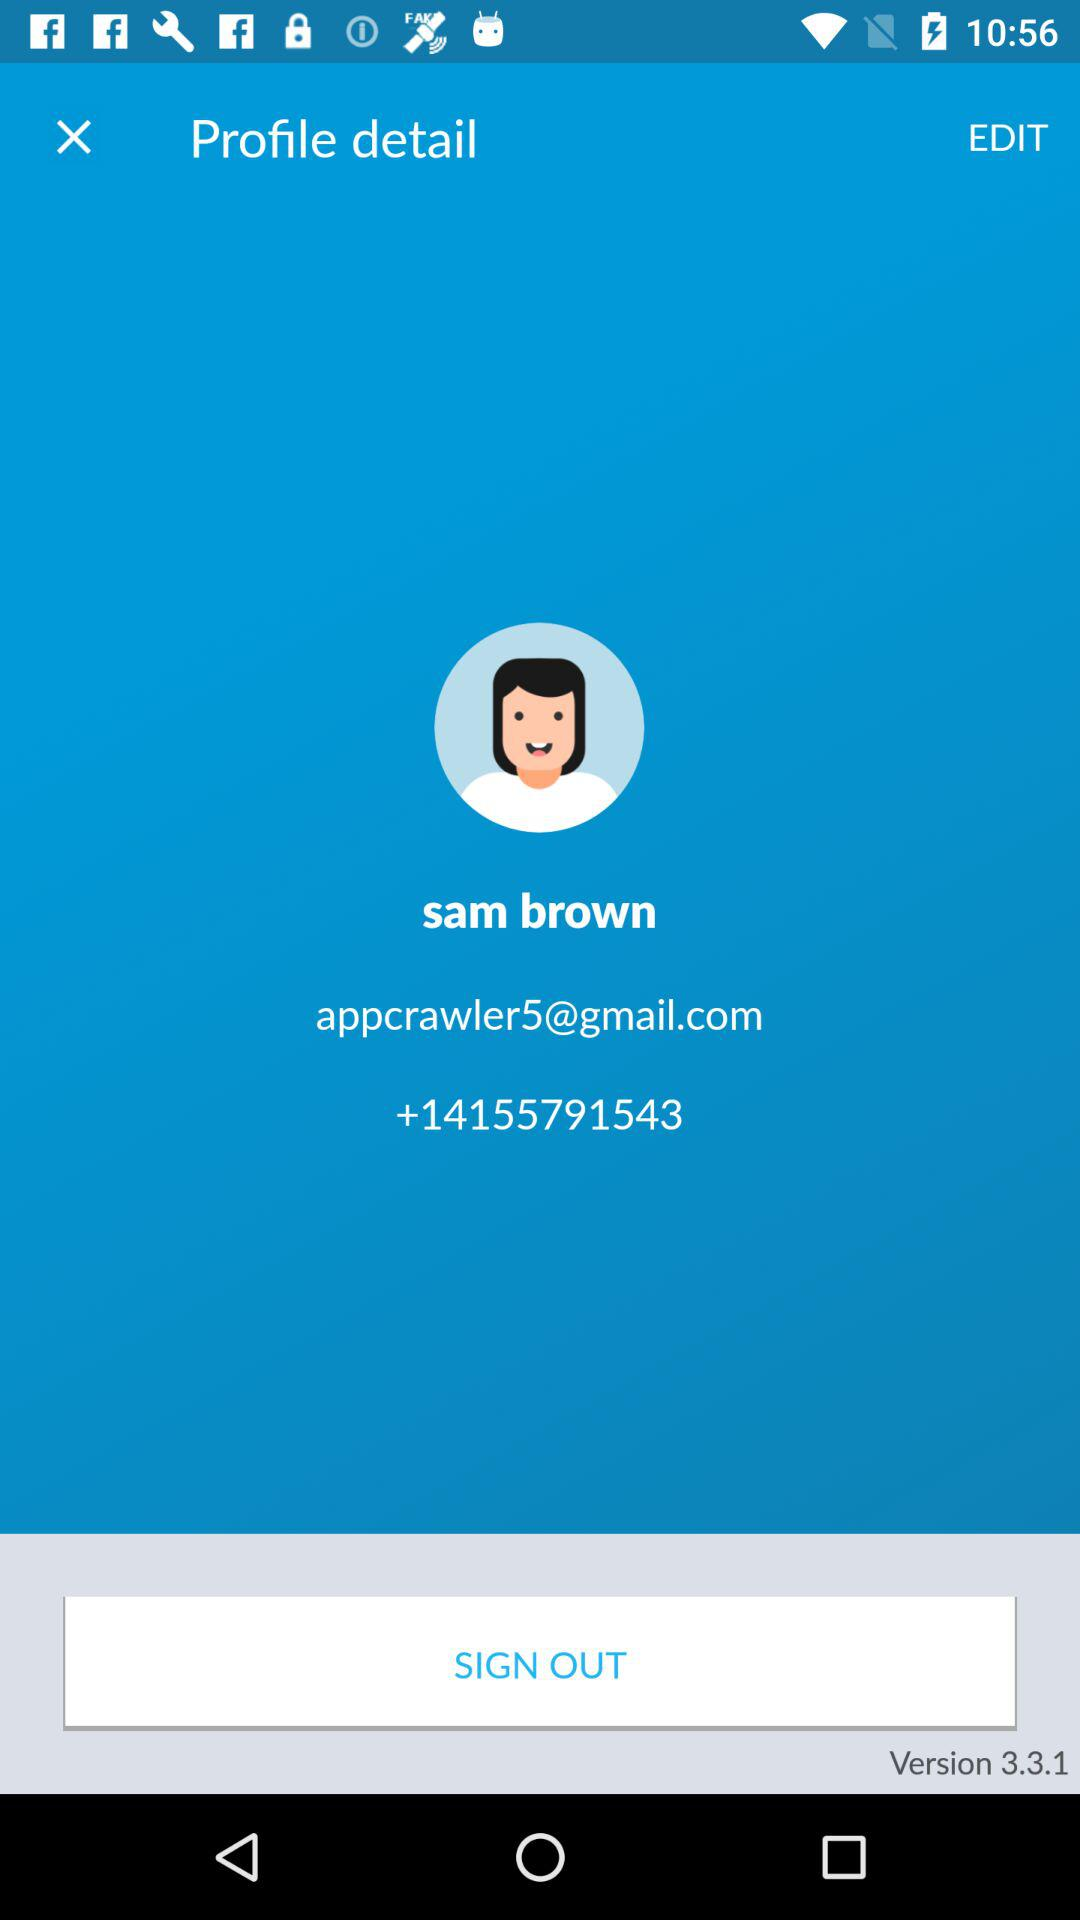What is the user name? The user name is sam brown. 